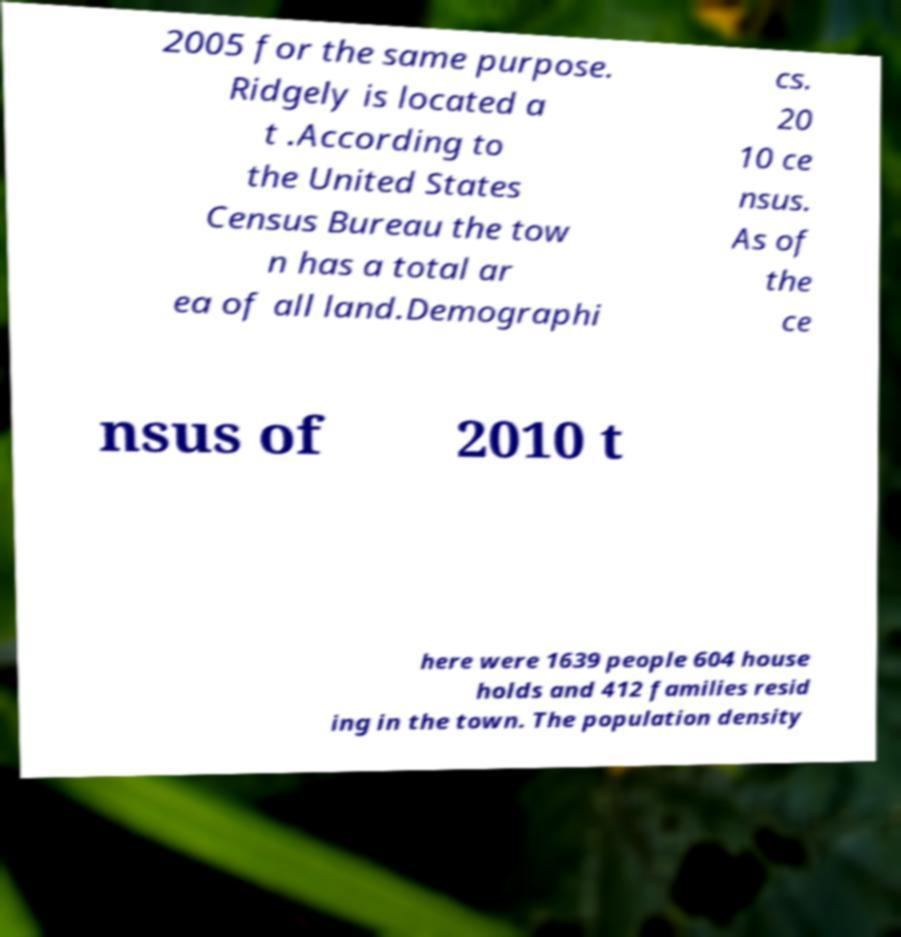Please identify and transcribe the text found in this image. 2005 for the same purpose. Ridgely is located a t .According to the United States Census Bureau the tow n has a total ar ea of all land.Demographi cs. 20 10 ce nsus. As of the ce nsus of 2010 t here were 1639 people 604 house holds and 412 families resid ing in the town. The population density 